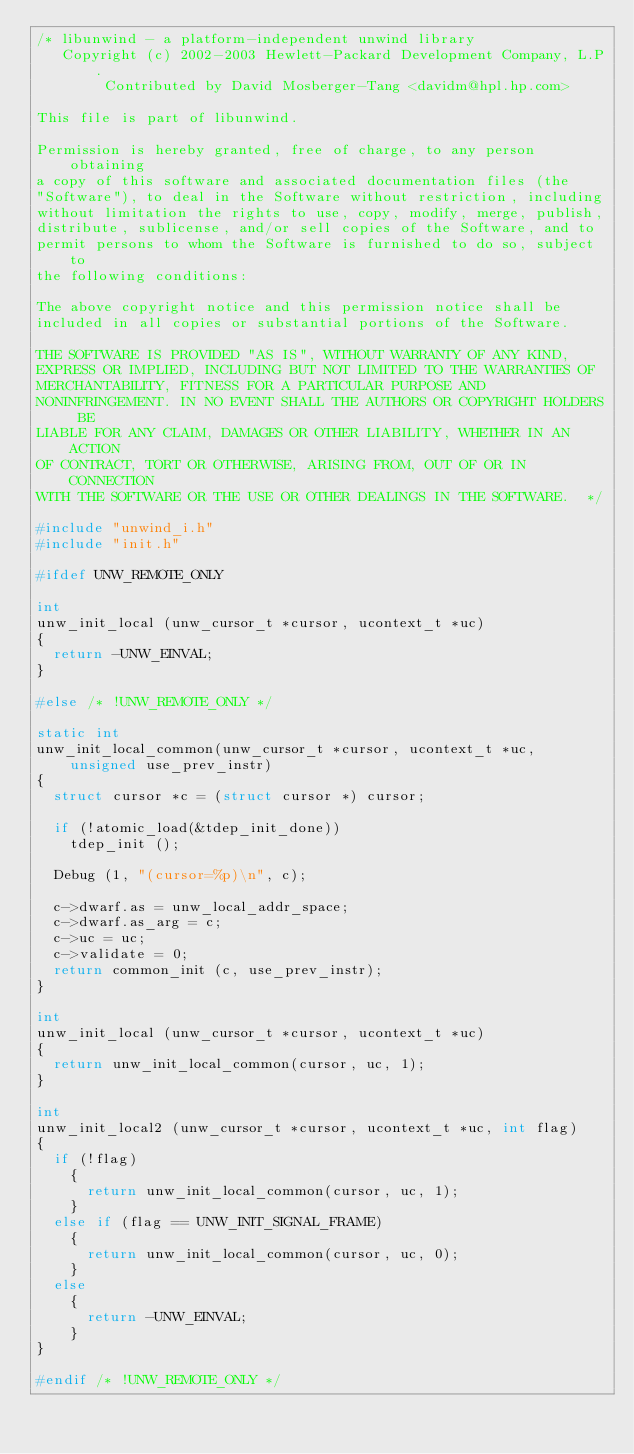<code> <loc_0><loc_0><loc_500><loc_500><_C_>/* libunwind - a platform-independent unwind library
   Copyright (c) 2002-2003 Hewlett-Packard Development Company, L.P.
        Contributed by David Mosberger-Tang <davidm@hpl.hp.com>

This file is part of libunwind.

Permission is hereby granted, free of charge, to any person obtaining
a copy of this software and associated documentation files (the
"Software"), to deal in the Software without restriction, including
without limitation the rights to use, copy, modify, merge, publish,
distribute, sublicense, and/or sell copies of the Software, and to
permit persons to whom the Software is furnished to do so, subject to
the following conditions:

The above copyright notice and this permission notice shall be
included in all copies or substantial portions of the Software.

THE SOFTWARE IS PROVIDED "AS IS", WITHOUT WARRANTY OF ANY KIND,
EXPRESS OR IMPLIED, INCLUDING BUT NOT LIMITED TO THE WARRANTIES OF
MERCHANTABILITY, FITNESS FOR A PARTICULAR PURPOSE AND
NONINFRINGEMENT. IN NO EVENT SHALL THE AUTHORS OR COPYRIGHT HOLDERS BE
LIABLE FOR ANY CLAIM, DAMAGES OR OTHER LIABILITY, WHETHER IN AN ACTION
OF CONTRACT, TORT OR OTHERWISE, ARISING FROM, OUT OF OR IN CONNECTION
WITH THE SOFTWARE OR THE USE OR OTHER DEALINGS IN THE SOFTWARE.  */

#include "unwind_i.h"
#include "init.h"

#ifdef UNW_REMOTE_ONLY

int
unw_init_local (unw_cursor_t *cursor, ucontext_t *uc)
{
  return -UNW_EINVAL;
}

#else /* !UNW_REMOTE_ONLY */

static int
unw_init_local_common(unw_cursor_t *cursor, ucontext_t *uc, unsigned use_prev_instr)
{
  struct cursor *c = (struct cursor *) cursor;

  if (!atomic_load(&tdep_init_done))
    tdep_init ();

  Debug (1, "(cursor=%p)\n", c);

  c->dwarf.as = unw_local_addr_space;
  c->dwarf.as_arg = c;
  c->uc = uc;
  c->validate = 0;
  return common_init (c, use_prev_instr);
}

int
unw_init_local (unw_cursor_t *cursor, ucontext_t *uc)
{
  return unw_init_local_common(cursor, uc, 1);
}

int
unw_init_local2 (unw_cursor_t *cursor, ucontext_t *uc, int flag)
{
  if (!flag)
    {
      return unw_init_local_common(cursor, uc, 1);
    }
  else if (flag == UNW_INIT_SIGNAL_FRAME)
    {
      return unw_init_local_common(cursor, uc, 0);
    }
  else
    {
      return -UNW_EINVAL;
    }
}

#endif /* !UNW_REMOTE_ONLY */
</code> 